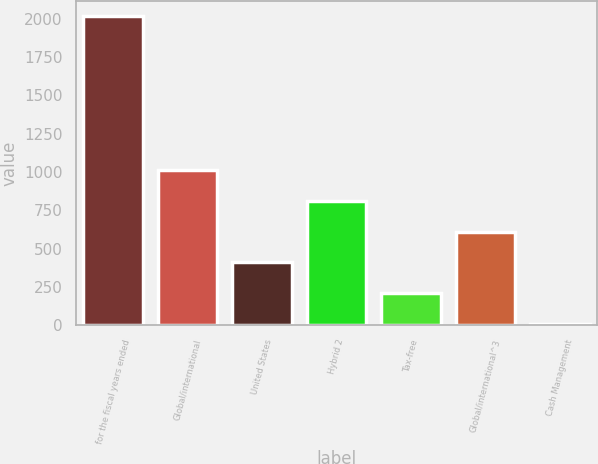<chart> <loc_0><loc_0><loc_500><loc_500><bar_chart><fcel>for the fiscal years ended<fcel>Global/international<fcel>United States<fcel>Hybrid 2<fcel>Tax-free<fcel>Global/international^3<fcel>Cash Management<nl><fcel>2015<fcel>1012<fcel>410.2<fcel>811.4<fcel>209.6<fcel>610.8<fcel>9<nl></chart> 